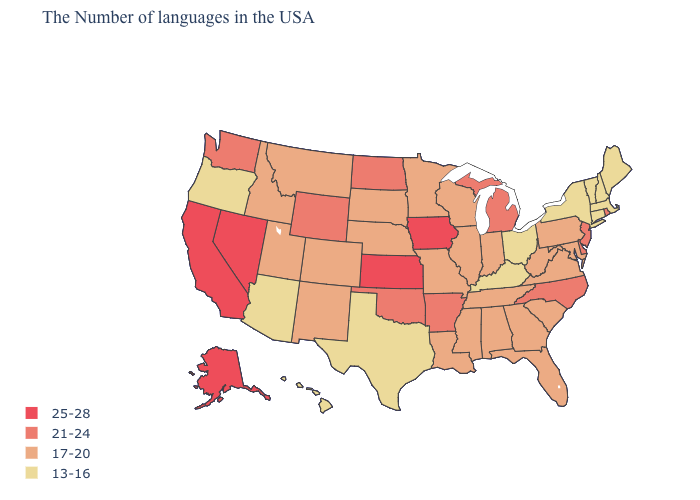What is the lowest value in the South?
Quick response, please. 13-16. What is the value of Montana?
Keep it brief. 17-20. Name the states that have a value in the range 13-16?
Keep it brief. Maine, Massachusetts, New Hampshire, Vermont, Connecticut, New York, Ohio, Kentucky, Texas, Arizona, Oregon, Hawaii. Among the states that border Massachusetts , does New Hampshire have the lowest value?
Give a very brief answer. Yes. Which states hav the highest value in the West?
Keep it brief. Nevada, California, Alaska. Name the states that have a value in the range 17-20?
Answer briefly. Maryland, Pennsylvania, Virginia, South Carolina, West Virginia, Florida, Georgia, Indiana, Alabama, Tennessee, Wisconsin, Illinois, Mississippi, Louisiana, Missouri, Minnesota, Nebraska, South Dakota, Colorado, New Mexico, Utah, Montana, Idaho. Does Wisconsin have the lowest value in the MidWest?
Quick response, please. No. Which states hav the highest value in the MidWest?
Give a very brief answer. Iowa, Kansas. What is the highest value in the USA?
Concise answer only. 25-28. What is the lowest value in the USA?
Quick response, please. 13-16. Does Ohio have the lowest value in the MidWest?
Be succinct. Yes. What is the highest value in the South ?
Be succinct. 21-24. Name the states that have a value in the range 21-24?
Answer briefly. Rhode Island, New Jersey, Delaware, North Carolina, Michigan, Arkansas, Oklahoma, North Dakota, Wyoming, Washington. What is the lowest value in the South?
Quick response, please. 13-16. What is the value of New Jersey?
Give a very brief answer. 21-24. 